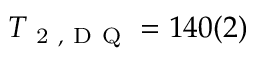Convert formula to latex. <formula><loc_0><loc_0><loc_500><loc_500>T _ { 2 , D Q } = 1 4 0 ( 2 )</formula> 